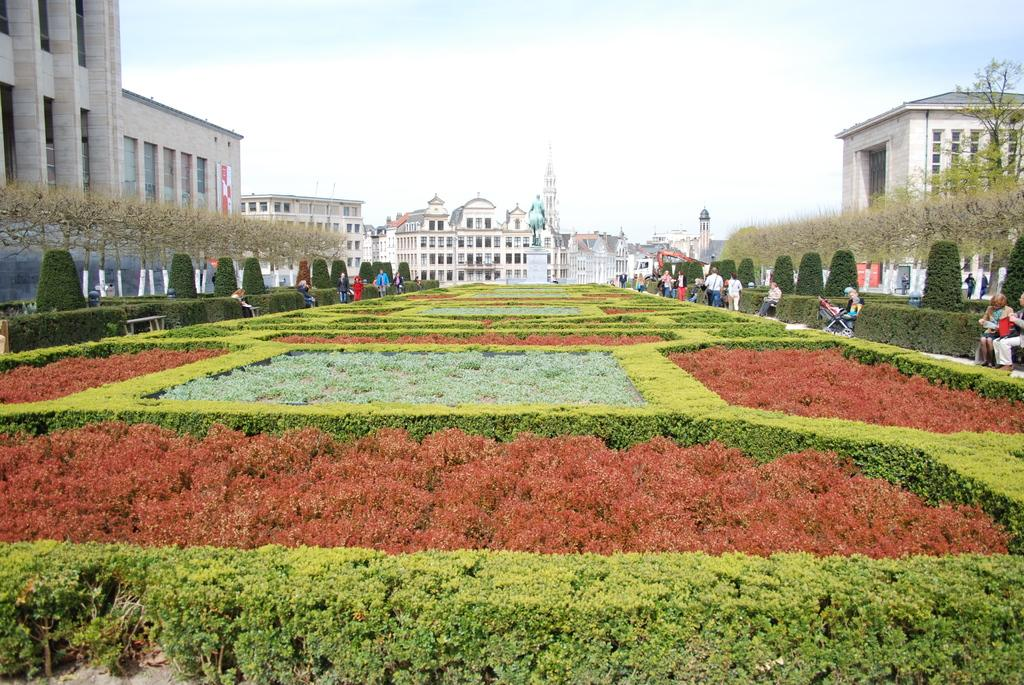Who or what can be seen in the image? There are people in the image. What else is present in the image besides people? There are plants, benches, trees, buildings, and the sky is visible in the background of the image. Can you describe the setting of the image? The image features a combination of natural elements, such as plants and trees, and man-made structures, like benches and buildings, with the sky visible in the background. What is the name of the event taking place in the image? There is no specific event mentioned or depicted in the image. What time of day is it in the image, based on the hour? The provided facts do not include information about the time of day or the hour, so it cannot be determined from the image. 